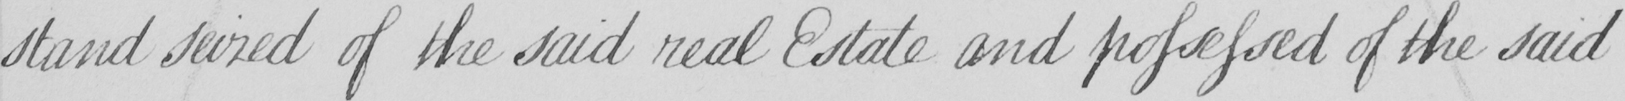Can you tell me what this handwritten text says? stand seized of the said real Estate and possessed of the said 